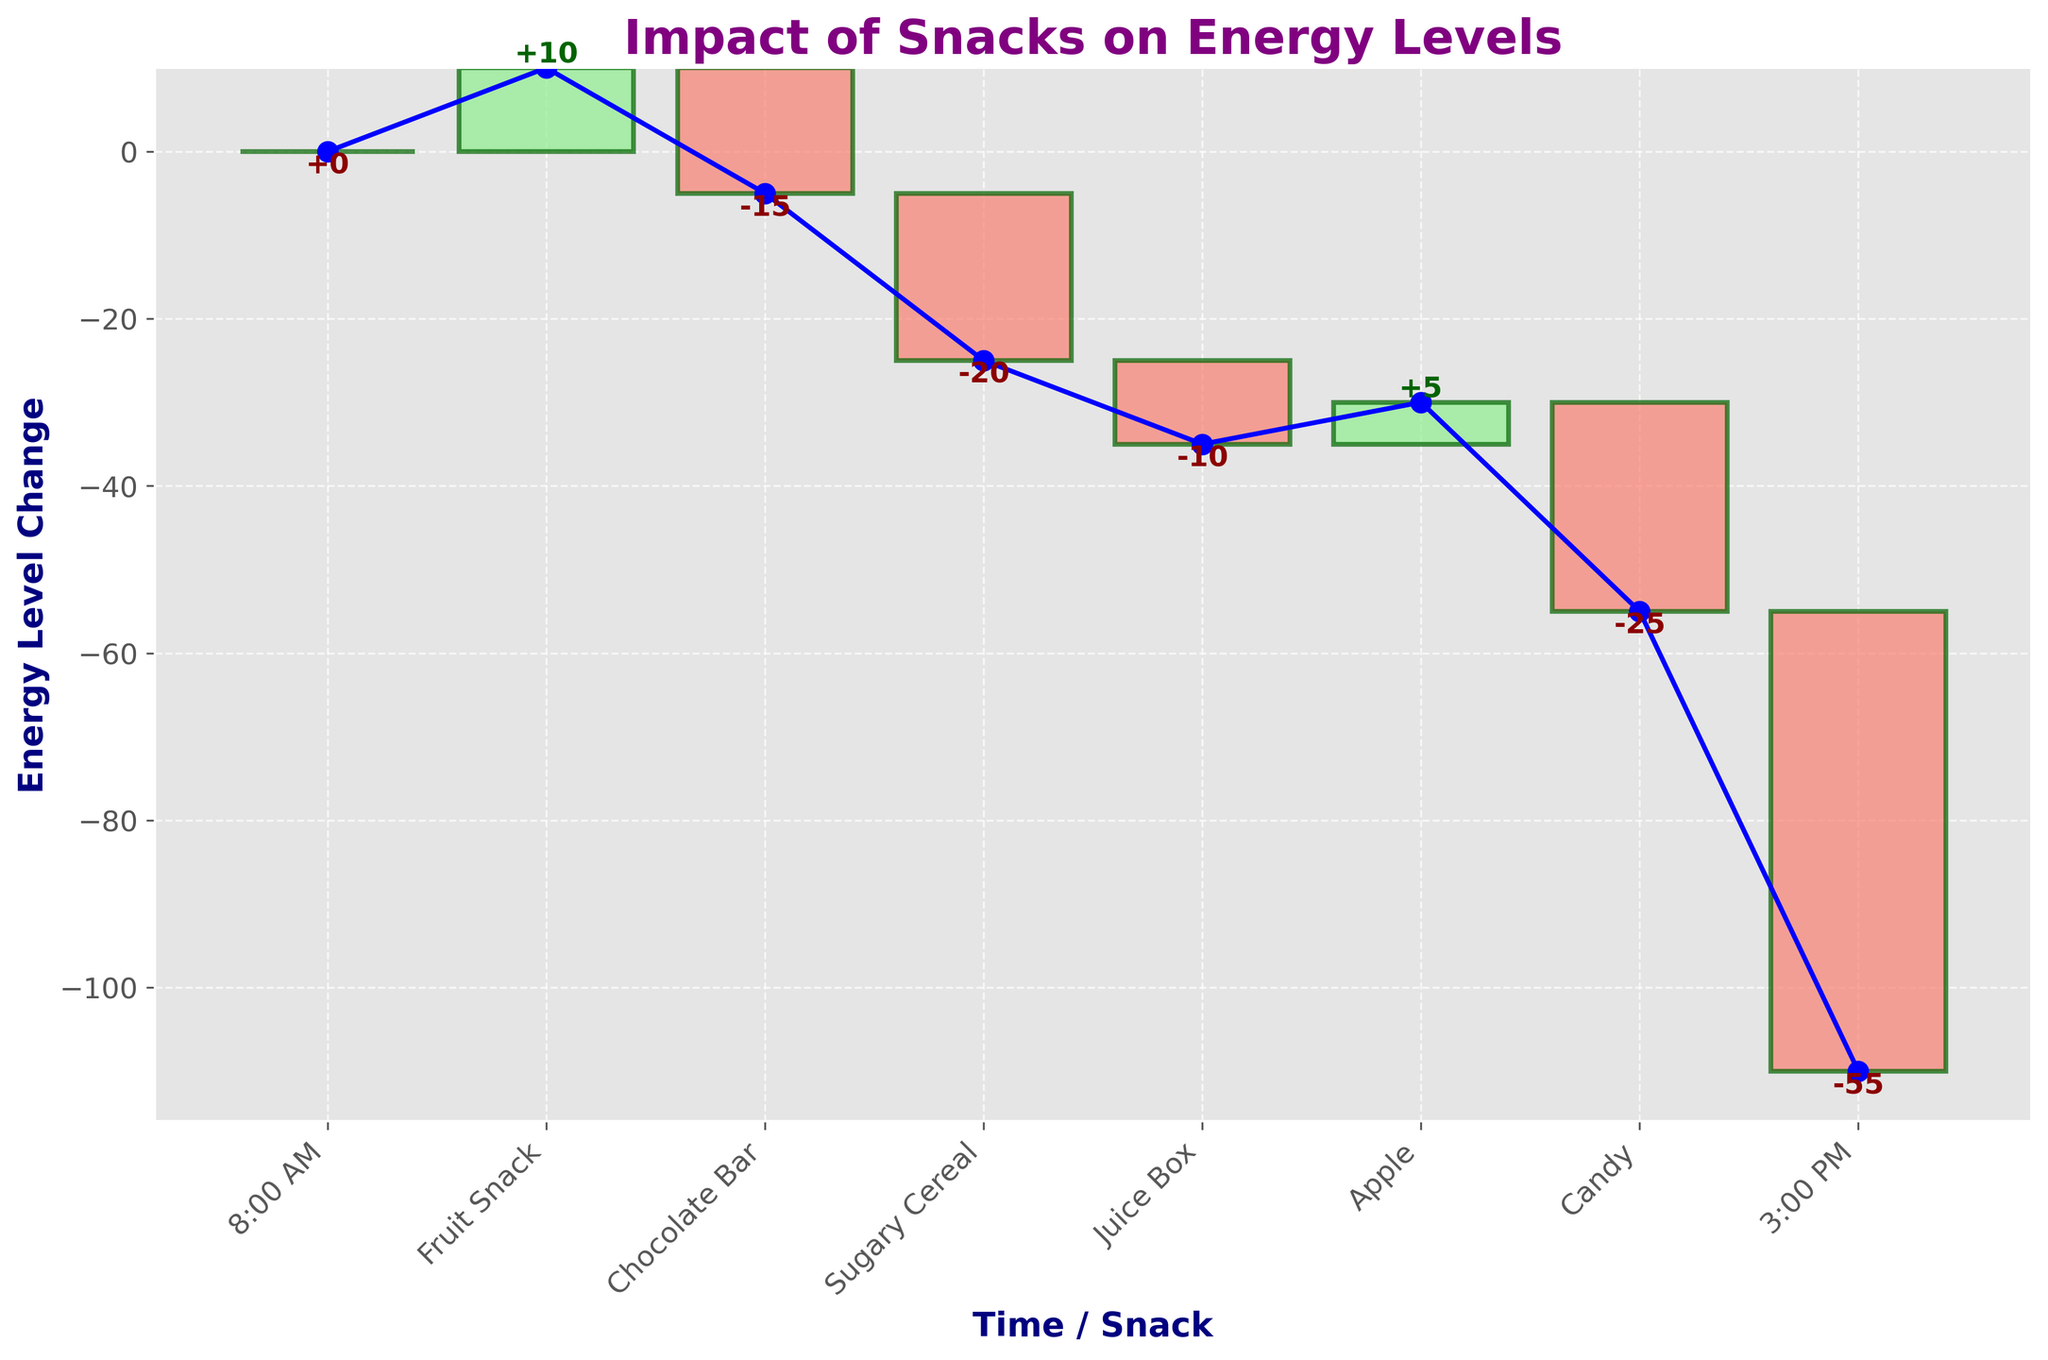What is the title of the chart? The title of the chart is typically found at the top center. By looking at the figure, it shows "Impact of Snacks on Energy Levels".
Answer: Impact of Snacks on Energy Levels What are the labels on the x-axis? The x-axis labels are visible on the bottom of the chart. The labels include times and snack names: "8:00 AM", "Fruit Snack", "Chocolate Bar", "Sugary Cereal", "Juice Box", "Apple", "Candy", and "3:00 PM".
Answer: 8:00 AM, Fruit Snack, Chocolate Bar, Sugary Cereal, Juice Box, Apple, Candy, 3:00 PM How does eating an apple affect the energy level? By looking at the chart, we can see a bar labeled "Apple". The value of this bar is +5, indicating that eating an apple increases the energy level by 5 units.
Answer: +5 How much does the candy decrease the energy level? The label "Candy" on the x-axis corresponds to a bar chart that indicates a value change in energy levels. The bar shows a decrease of -25.
Answer: -25 What is the overall energy level change from 8:00 AM to 3:00 PM? To find the overall change, look at the cumulative sum of changes from the start to the end points. The energy starts at 0 at 8:00 AM and ends at -55 at 3:00 PM.
Answer: -55 Which snack caused the largest decrease in energy levels? Comparing the values of all the snacks, the "Candy" bar leads to the largest single decrease in energy levels, as it has the most negative value at -25.
Answer: Candy Which two snacks together contribute to a neutral energy level change? For a neutral change, look for two snacks whose changes sum to zero. "Fruit Snack" at +10 and "Chocolate Bar" at -15 come close, but doing a better computation shows that "Apple" at +5 and "Juice Box" at -10 sum closer to zero but not possible the exact zero with others. So no exact neutral (zero) with two snacks alone here.
Answer: None If I eat a fruit snack and then a chocolate bar, what will be my energy level change? First, find the individual changes: Fruit Snack is +10 and Chocolate Bar is -15. Adding them together, 10 + (-15) = -5.
Answer: -5 What is the total decrease in energy level after eating the sugary cereal, juice box, and candy? Sum the energy changes from these snacks: Sugary Cereal (-20), Juice Box (-10), Candy (-25). The total decrease is -20 + (-10) + (-25) = -55.
Answer: -55 